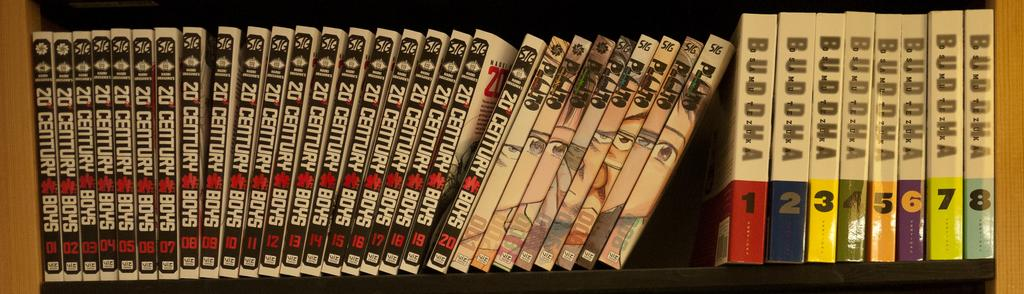<image>
Render a clear and concise summary of the photo. Copies of 20 Century Boys sit on the shelf along with other dvds. 